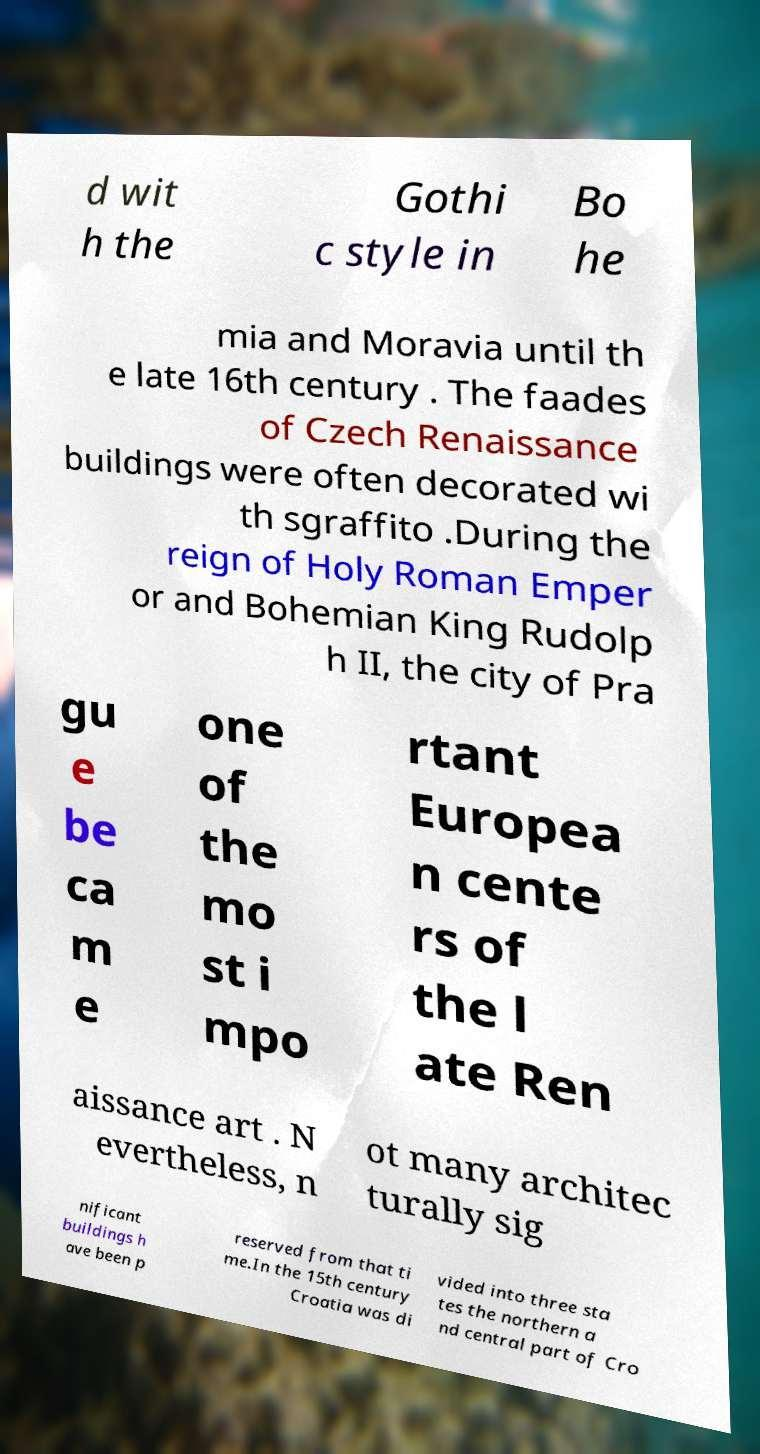Can you read and provide the text displayed in the image?This photo seems to have some interesting text. Can you extract and type it out for me? d wit h the Gothi c style in Bo he mia and Moravia until th e late 16th century . The faades of Czech Renaissance buildings were often decorated wi th sgraffito .During the reign of Holy Roman Emper or and Bohemian King Rudolp h II, the city of Pra gu e be ca m e one of the mo st i mpo rtant Europea n cente rs of the l ate Ren aissance art . N evertheless, n ot many architec turally sig nificant buildings h ave been p reserved from that ti me.In the 15th century Croatia was di vided into three sta tes the northern a nd central part of Cro 